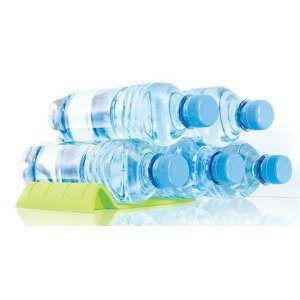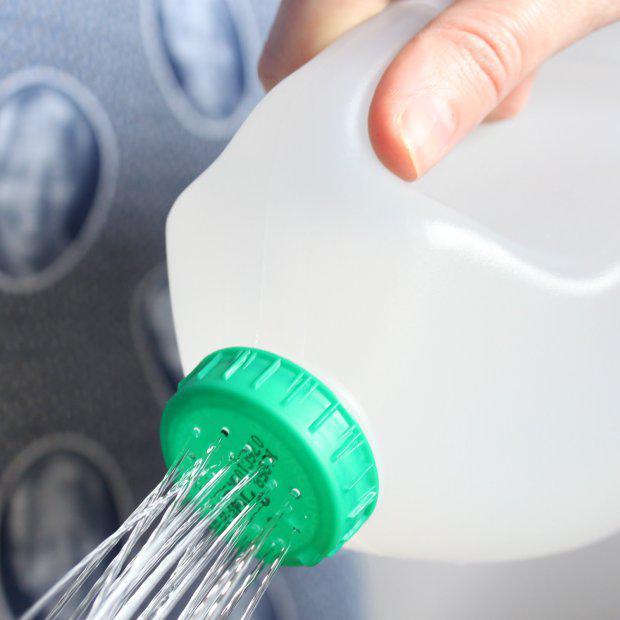The first image is the image on the left, the second image is the image on the right. Assess this claim about the two images: "At least one container in the image on the right is destroyed.". Correct or not? Answer yes or no. No. 